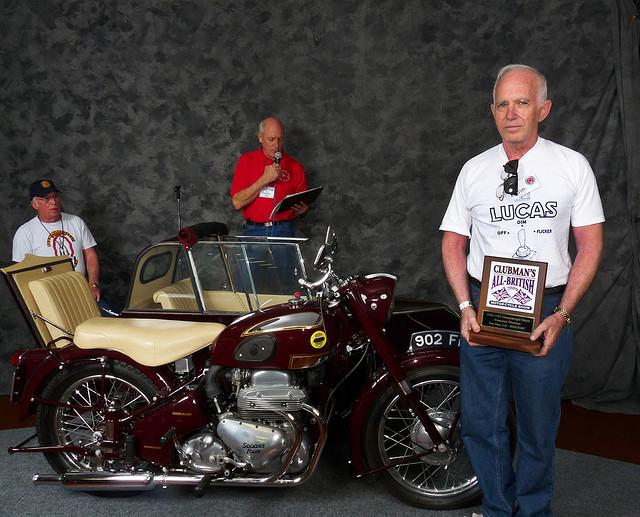Why is the man holding a microphone? Please explain your reasoning. he's speaking. The man wants to confirm that people can hear him. 